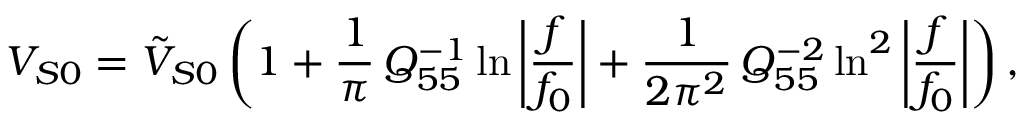<formula> <loc_0><loc_0><loc_500><loc_500>V _ { S 0 } = \tilde { V } _ { S 0 } \left ( 1 + \frac { 1 } { \pi } \, Q _ { 5 5 } ^ { - 1 } \ln { \left | \frac { f } { f _ { 0 } } \right | } + \frac { 1 } { 2 \pi ^ { 2 } } \, Q _ { 5 5 } ^ { - 2 } \ln ^ { 2 } { \left | \frac { f } { f _ { 0 } } \right | } \right ) ,</formula> 